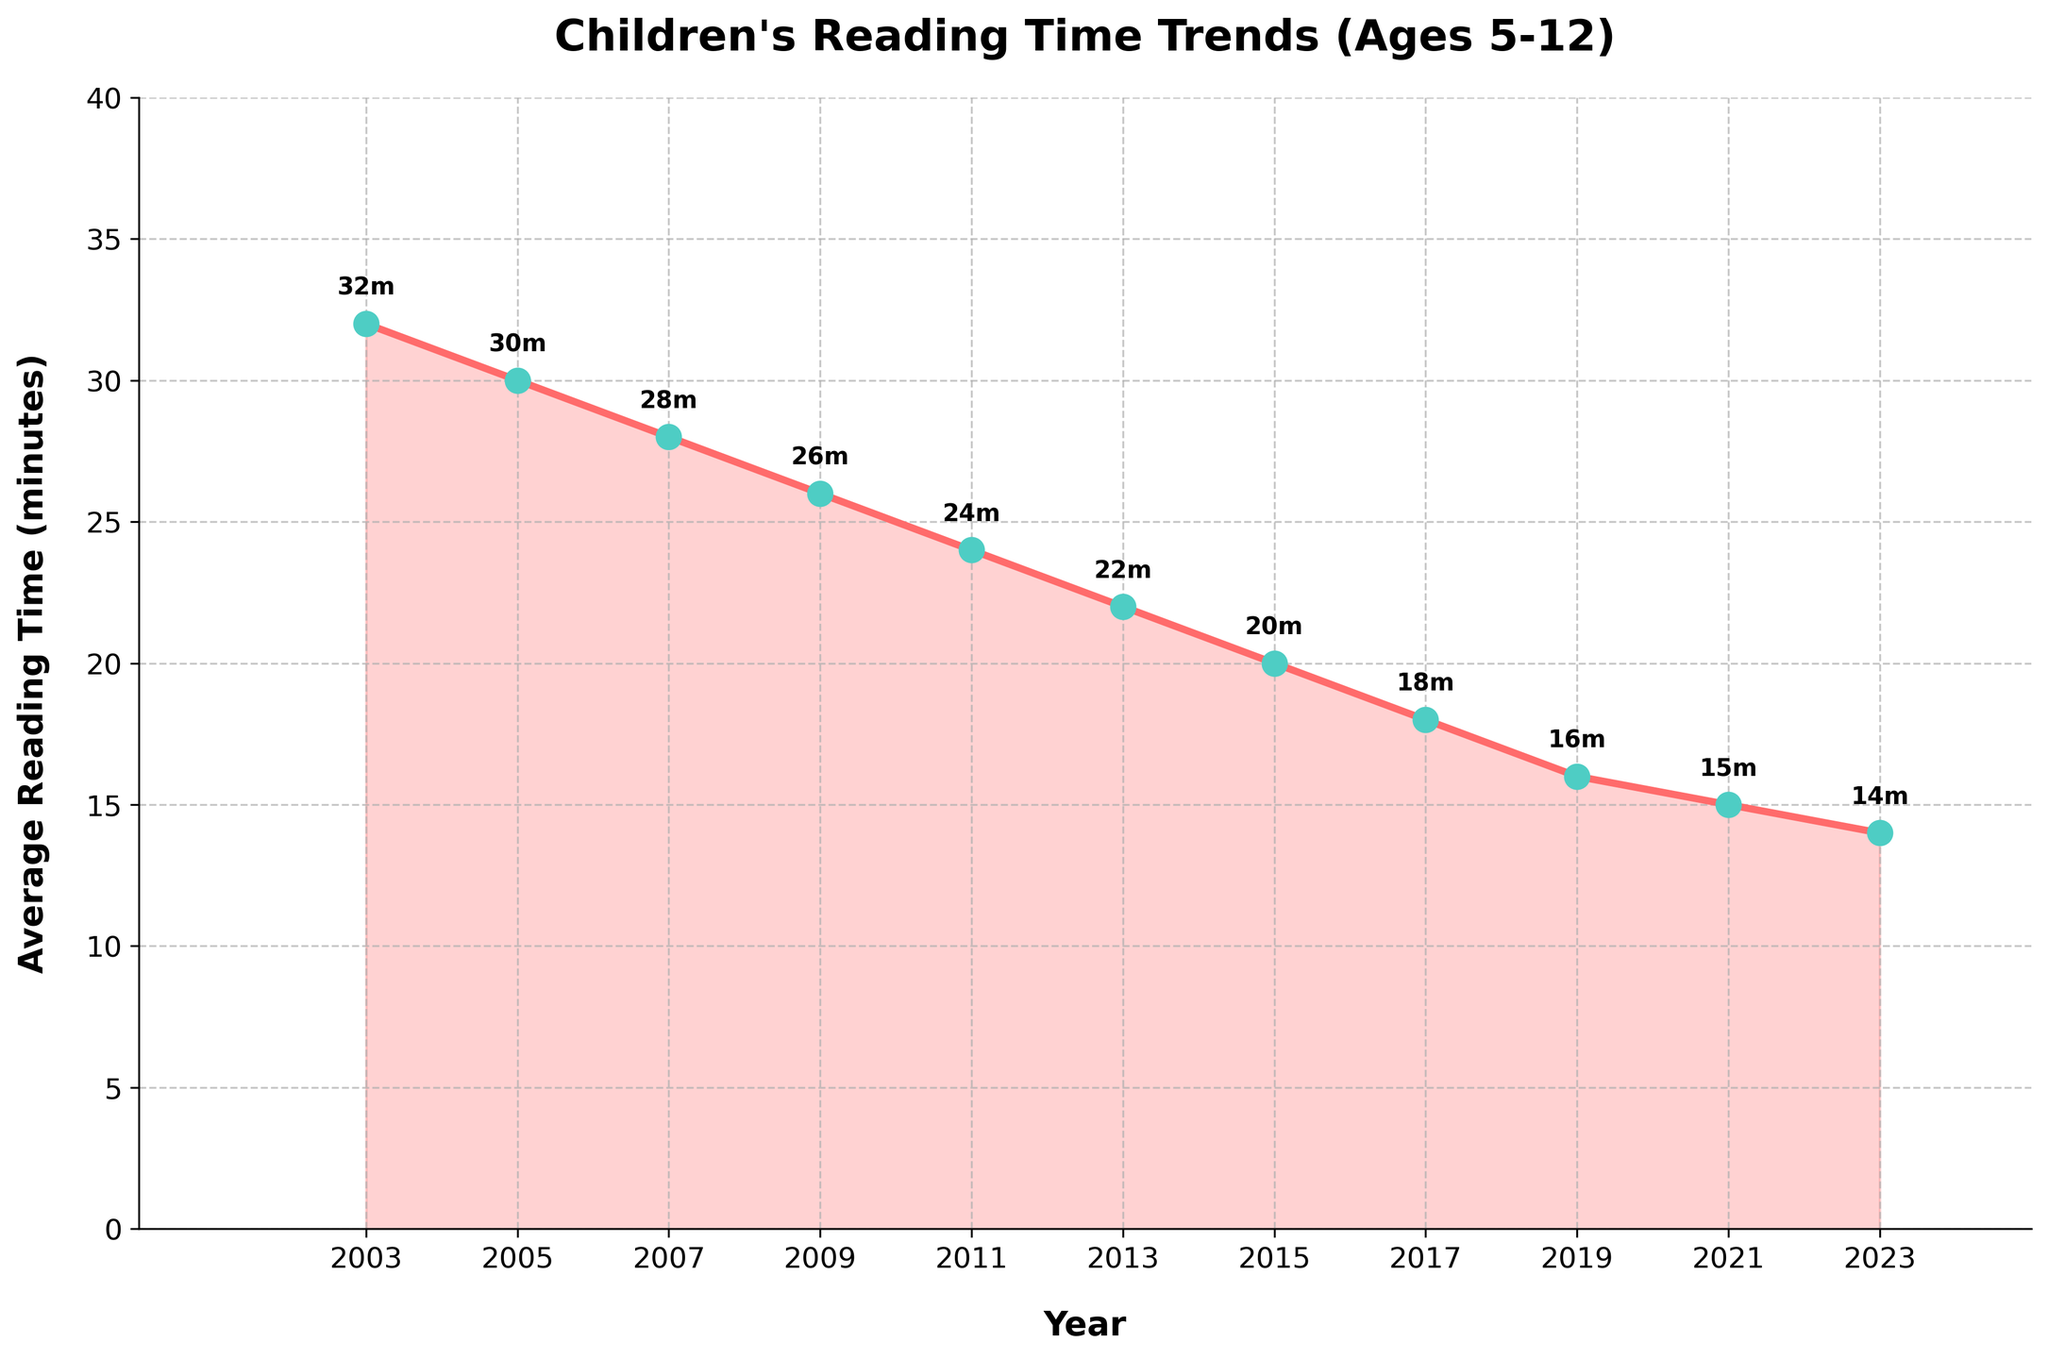What is the average reading time for children in 2023? To find the average reading time for children in 2023, locate the point on the chart corresponding to the year 2023. The average reading time is labeled directly on that point.
Answer: 14 minutes How did the average reading time change between 2003 and 2023? First, find the average reading time for 2003 and 2023. In 2003, it was 32 minutes, and in 2023, it was 14 minutes. Subtract 14 from 32 to get the change.
Answer: Decreased by 18 minutes What is the range of average reading times from 2003 to 2023? To find the range, identify the maximum and minimum reading times in the given years. The maximum is 32 minutes in 2003, and the minimum is 14 minutes in 2023. Subtract the minimum from the maximum to find the range.
Answer: 18 minutes In which year did the average reading time first fall below 20 minutes? Locate the points on the chart, and identify the year when the reading time dropped below 20 minutes. This occurred in 2015, where the average reading time was 20 minutes.
Answer: 2015 Compare the average reading times in 2007 and 2023. Which year had a higher value, and by how much? Find the values for 2007 and 2023 on the chart. In 2007, it was 28 minutes, and in 2023, it was 14 minutes. Subtract 14 from 28 to find the difference.
Answer: 2007 had 14 more minutes What is the total decrease in reading time from 2003 to 2011? Find the reading times in 2003 and 2011, which are 32 and 24 minutes, respectively. The total decrease is the difference between these values.
Answer: 8 minutes Identify the year when the average reading time dropped by 2 minutes compared to the previous year. Scan the chart for points where the year labels show a 2-minute drop from the previous year. For example, from 2003 to 2005, the reading time decreased from 32 to 30 minutes (a 2-minute drop). This also happened from 2005 to 2007, and so on.
Answer: 2003 to 2005 (also occurs from 2005 to 2007, 2007 to 2009, etc.) What broad trend can be observed in children's reading time from 2003 to 2023? Examine the progression of the points on the chart. There's a clear downward trend where the reading time gradually decreases from 32 minutes in 2003 to 14 minutes in 2023.
Answer: Decreasing trend How many years did it take for the average reading time to halve from its 2003 value? The 2003 value is 32 minutes. Half of this value is 16 minutes. Locate the year when the reading time first reaches or drops below 16 minutes. It reached 16 minutes in 2019.
Answer: 16 years (2003 to 2019) 